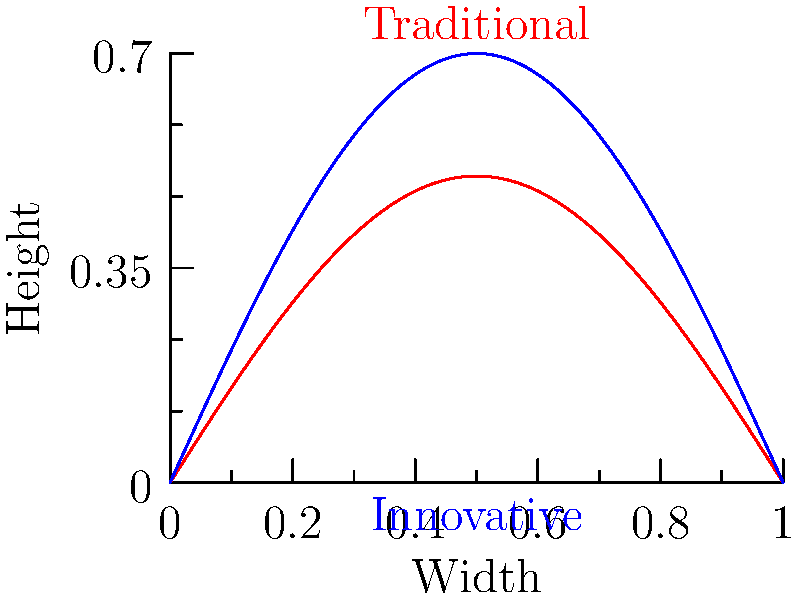Consider the graph showing two different bridge curvature profiles for violins. The red curve represents a traditional bridge design, while the blue curve shows an innovative approach with a higher arc. Which profile is likely to provide better sound projection across all strings, and why? To determine which bridge curvature profile provides better sound projection, we need to consider several factors:

1. String clearance: The higher arc (blue curve) provides more clearance for the strings, allowing for greater vibration amplitude.

2. Energy transfer: The blue curve's steeper angle at the point where it meets the violin's body can lead to more efficient energy transfer from the strings to the instrument's body.

3. String equality: The blue curve's higher arc helps to equalize the height difference between the outer and inner strings, potentially balancing the sound across all four strings.

4. Harmonic content: The increased curvature of the blue profile may enhance the production of higher harmonics, contributing to a brighter, more projecting tone.

5. Structural integrity: While the blue curve may offer acoustic advantages, it's important to consider the structural implications of a higher arc, which may affect the bridge's stability and longevity.

6. Playing technique: A higher arc may require slight adjustments in bowing technique, particularly for string crossings.

Balancing these factors, the innovative (blue) profile is likely to provide better sound projection across all strings due to increased string clearance, more efficient energy transfer, and potentially more balanced string heights. However, this comes with the caveat that structural integrity and playability must be carefully considered in the final design.
Answer: Innovative (blue) profile, due to increased string clearance and energy transfer. 